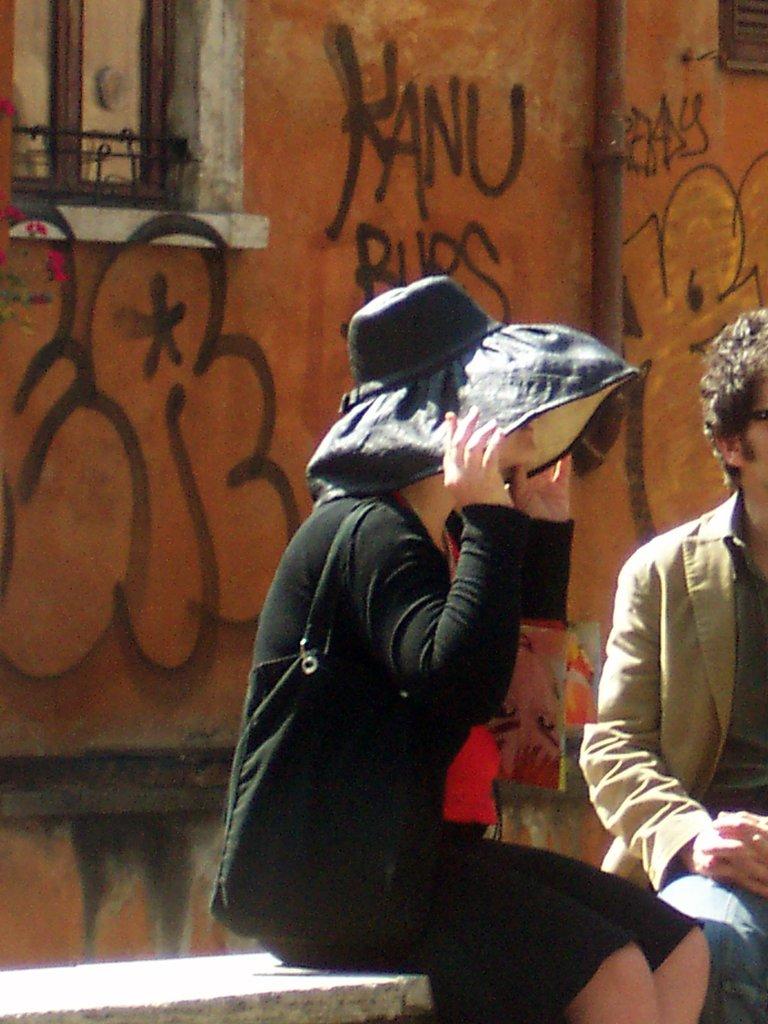What is the grafiti on the wall?
Give a very brief answer. Kanu. 